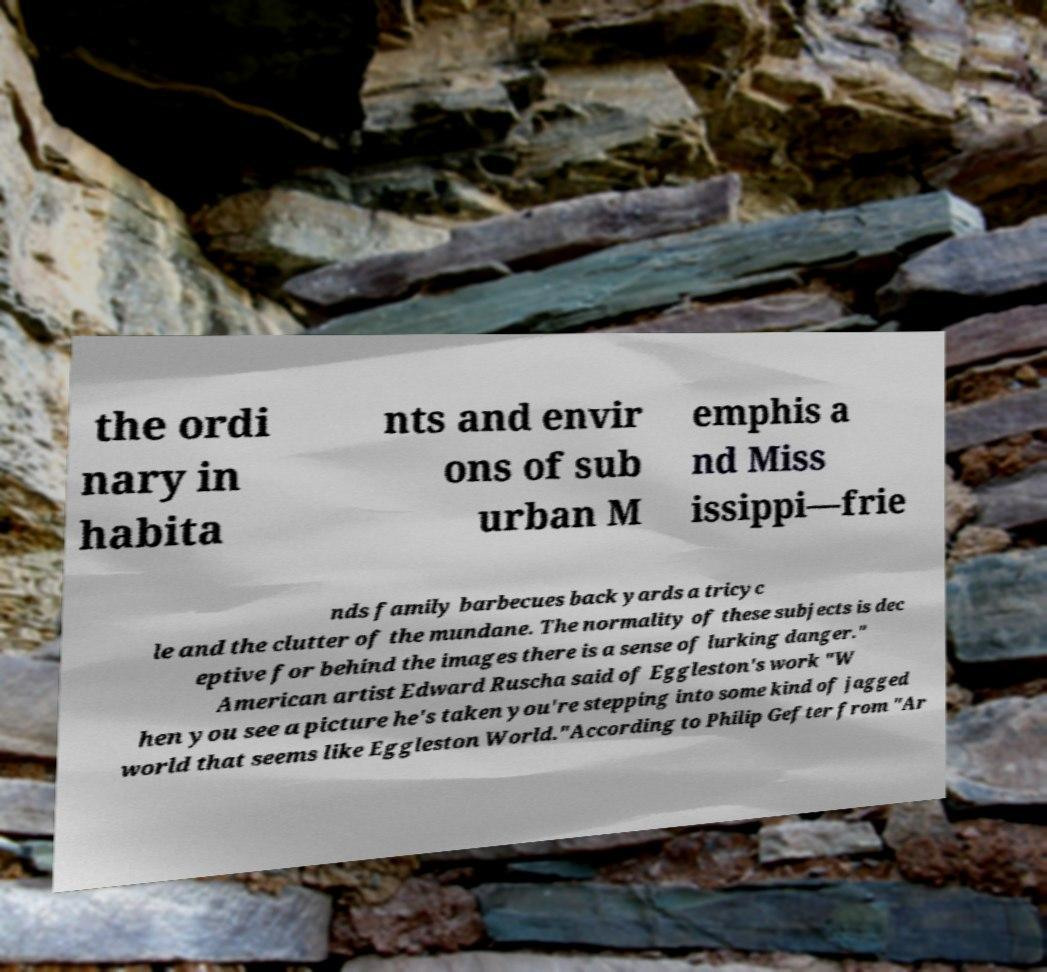There's text embedded in this image that I need extracted. Can you transcribe it verbatim? the ordi nary in habita nts and envir ons of sub urban M emphis a nd Miss issippi—frie nds family barbecues back yards a tricyc le and the clutter of the mundane. The normality of these subjects is dec eptive for behind the images there is a sense of lurking danger." American artist Edward Ruscha said of Eggleston's work "W hen you see a picture he's taken you're stepping into some kind of jagged world that seems like Eggleston World."According to Philip Gefter from "Ar 